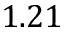<formula> <loc_0><loc_0><loc_500><loc_500>1 . 2 1</formula> 